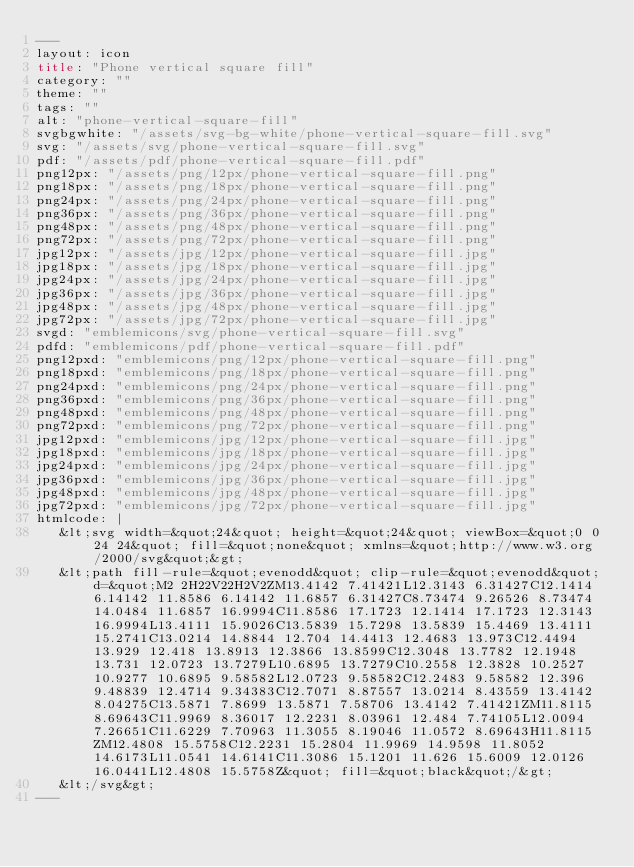Convert code to text. <code><loc_0><loc_0><loc_500><loc_500><_HTML_>---
layout: icon
title: "Phone vertical square fill"
category: ""
theme: ""
tags: ""
alt: "phone-vertical-square-fill"
svgbgwhite: "/assets/svg-bg-white/phone-vertical-square-fill.svg"
svg: "/assets/svg/phone-vertical-square-fill.svg"
pdf: "/assets/pdf/phone-vertical-square-fill.pdf"
png12px: "/assets/png/12px/phone-vertical-square-fill.png"
png18px: "/assets/png/18px/phone-vertical-square-fill.png"
png24px: "/assets/png/24px/phone-vertical-square-fill.png"
png36px: "/assets/png/36px/phone-vertical-square-fill.png"
png48px: "/assets/png/48px/phone-vertical-square-fill.png"
png72px: "/assets/png/72px/phone-vertical-square-fill.png"
jpg12px: "/assets/jpg/12px/phone-vertical-square-fill.jpg"
jpg18px: "/assets/jpg/18px/phone-vertical-square-fill.jpg"
jpg24px: "/assets/jpg/24px/phone-vertical-square-fill.jpg"
jpg36px: "/assets/jpg/36px/phone-vertical-square-fill.jpg"
jpg48px: "/assets/jpg/48px/phone-vertical-square-fill.jpg"
jpg72px: "/assets/jpg/72px/phone-vertical-square-fill.jpg"
svgd: "emblemicons/svg/phone-vertical-square-fill.svg"
pdfd: "emblemicons/pdf/phone-vertical-square-fill.pdf"
png12pxd: "emblemicons/png/12px/phone-vertical-square-fill.png"
png18pxd: "emblemicons/png/18px/phone-vertical-square-fill.png"
png24pxd: "emblemicons/png/24px/phone-vertical-square-fill.png"
png36pxd: "emblemicons/png/36px/phone-vertical-square-fill.png"
png48pxd: "emblemicons/png/48px/phone-vertical-square-fill.png"
png72pxd: "emblemicons/png/72px/phone-vertical-square-fill.png"
jpg12pxd: "emblemicons/jpg/12px/phone-vertical-square-fill.jpg"
jpg18pxd: "emblemicons/jpg/18px/phone-vertical-square-fill.jpg"
jpg24pxd: "emblemicons/jpg/24px/phone-vertical-square-fill.jpg"
jpg36pxd: "emblemicons/jpg/36px/phone-vertical-square-fill.jpg"
jpg48pxd: "emblemicons/jpg/48px/phone-vertical-square-fill.jpg"
jpg72pxd: "emblemicons/jpg/72px/phone-vertical-square-fill.jpg"
htmlcode: |
   &lt;svg width=&quot;24&quot; height=&quot;24&quot; viewBox=&quot;0 0 24 24&quot; fill=&quot;none&quot; xmlns=&quot;http://www.w3.org/2000/svg&quot;&gt;
   &lt;path fill-rule=&quot;evenodd&quot; clip-rule=&quot;evenodd&quot; d=&quot;M2 2H22V22H2V2ZM13.4142 7.41421L12.3143 6.31427C12.1414 6.14142 11.8586 6.14142 11.6857 6.31427C8.73474 9.26526 8.73474 14.0484 11.6857 16.9994C11.8586 17.1723 12.1414 17.1723 12.3143 16.9994L13.4111 15.9026C13.5839 15.7298 13.5839 15.4469 13.4111 15.2741C13.0214 14.8844 12.704 14.4413 12.4683 13.973C12.4494 13.929 12.418 13.8913 12.3866 13.8599C12.3048 13.7782 12.1948 13.731 12.0723 13.7279L10.6895 13.7279C10.2558 12.3828 10.2527 10.9277 10.6895 9.58582L12.0723 9.58582C12.2483 9.58582 12.396 9.48839 12.4714 9.34383C12.7071 8.87557 13.0214 8.43559 13.4142 8.04275C13.5871 7.8699 13.5871 7.58706 13.4142 7.41421ZM11.8115 8.69643C11.9969 8.36017 12.2231 8.03961 12.484 7.74105L12.0094 7.26651C11.6229 7.70963 11.3055 8.19046 11.0572 8.69643H11.8115ZM12.4808 15.5758C12.2231 15.2804 11.9969 14.9598 11.8052 14.6173L11.0541 14.6141C11.3086 15.1201 11.626 15.6009 12.0126 16.0441L12.4808 15.5758Z&quot; fill=&quot;black&quot;/&gt;
   &lt;/svg&gt;
---</code> 